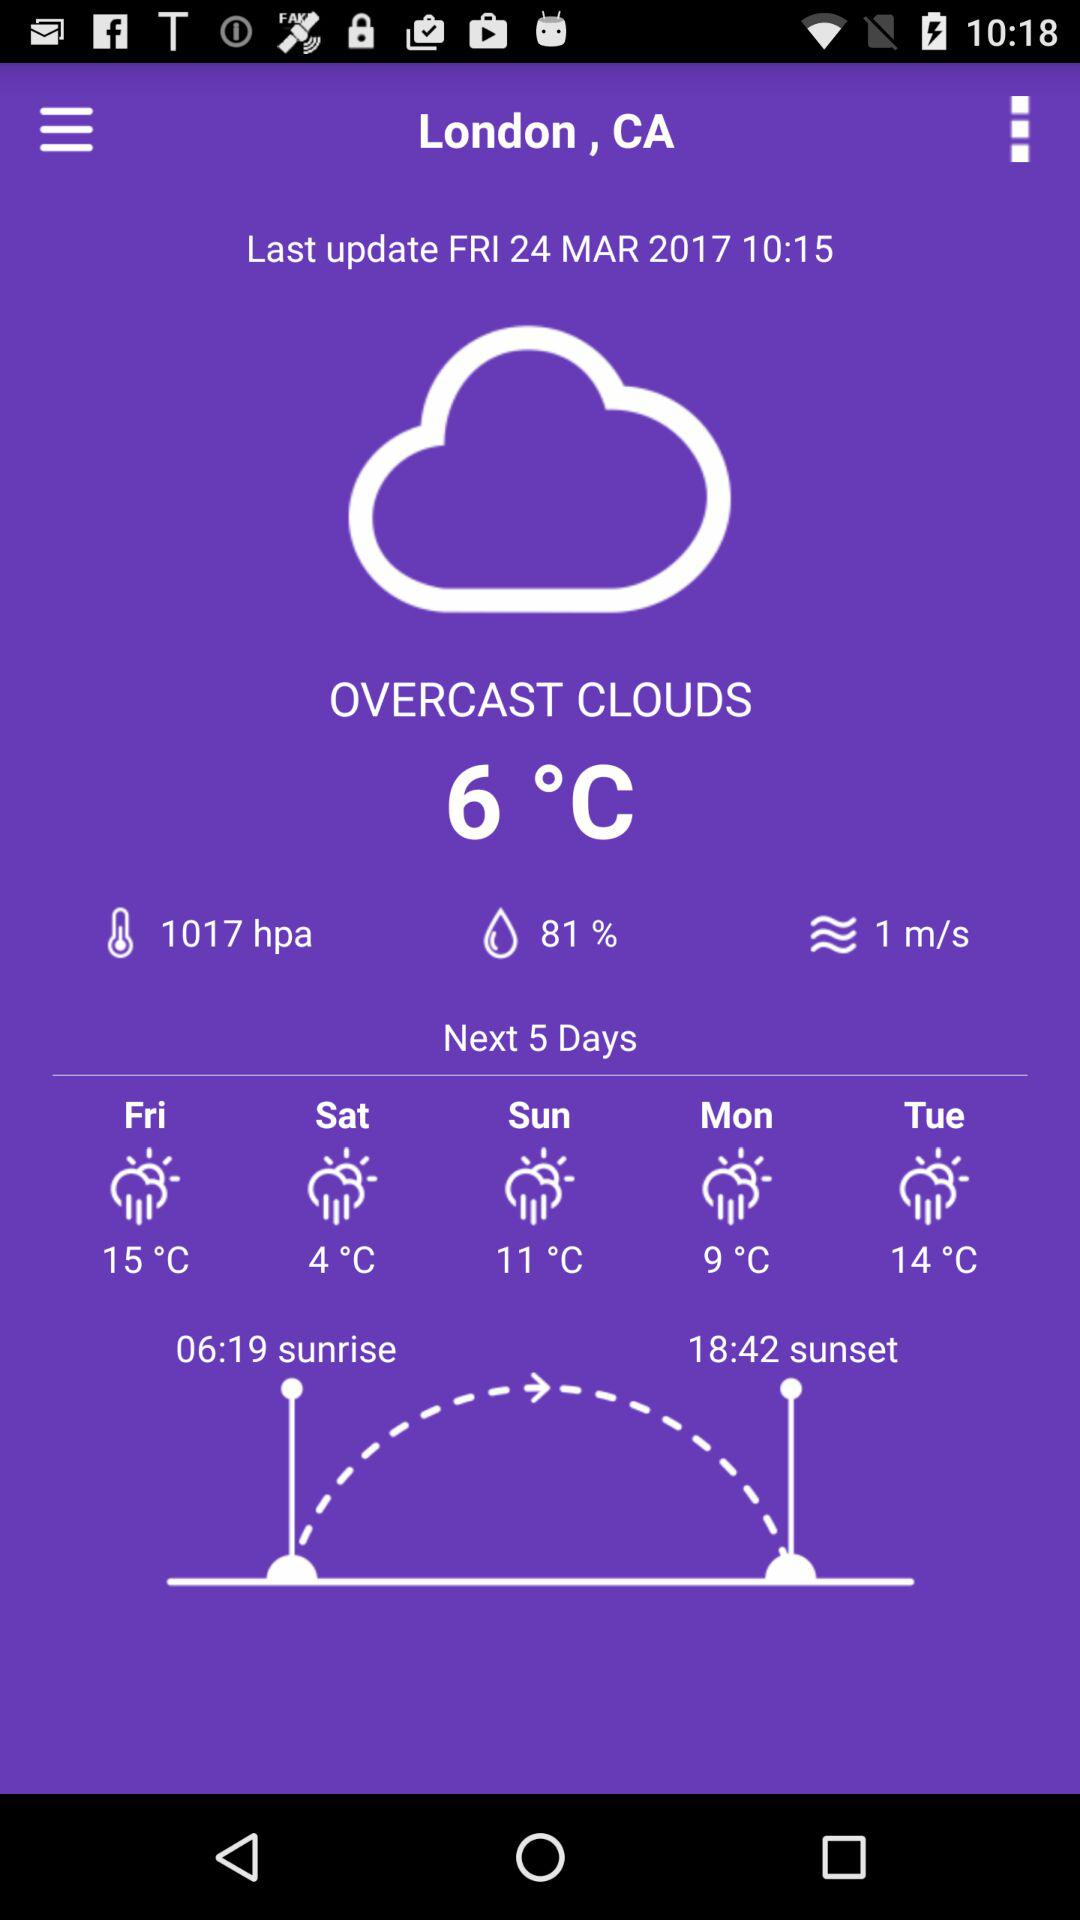What is the sunrise time? The sunrise time is 6:19 am. 